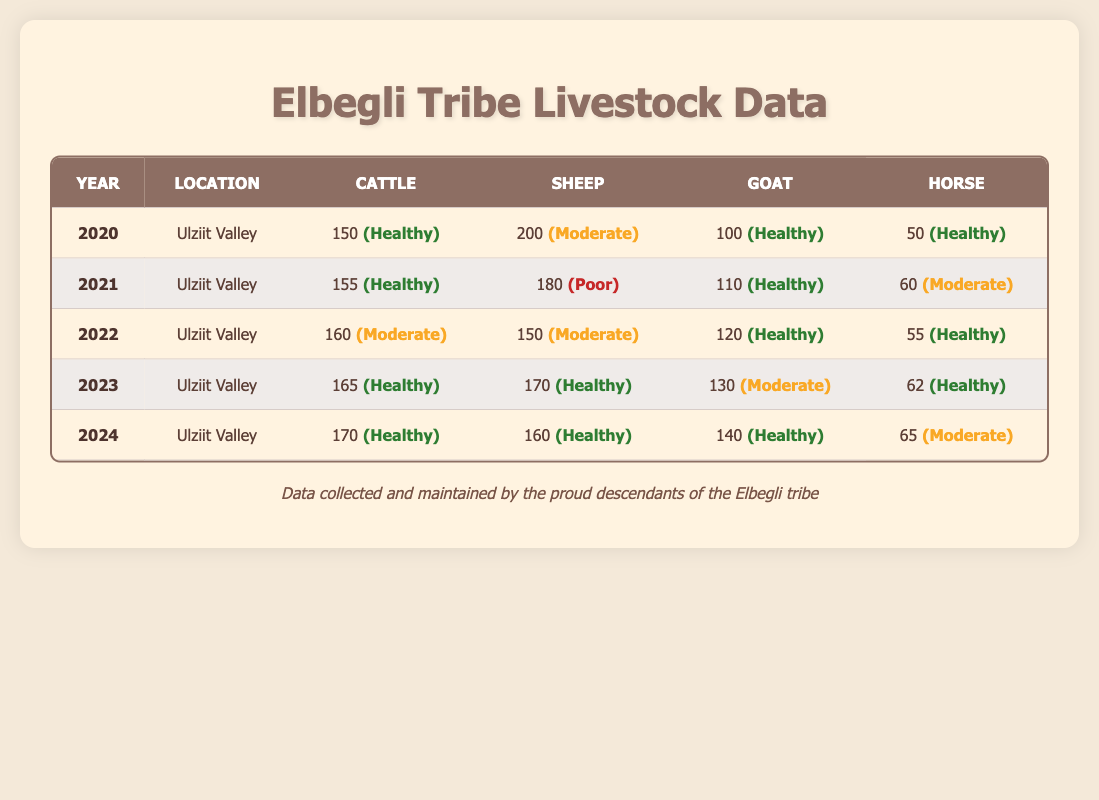What was the cattle count in 2022? The data for the year 2022 shows a cattle count of 160 in the Ulziit Valley.
Answer: 160 In which year did sheep health status drop to "Poor"? According to the table, the health status of sheep dropped to "Poor" in 2021.
Answer: 2021 What is the total number of horses counted from 2020 to 2024? The total horse counts for each year are 50 (2020) + 60 (2021) + 55 (2022) + 62 (2023) + 65 (2024) = 292.
Answer: 292 Which year had the highest number of sheep? The year 2020 had the highest sheep count of 200 in the data provided.
Answer: 2020 Is the health status of goats in 2024 healthy? Yes, the health status of goats in 2024 is indicated as "Healthy" in the table.
Answer: Yes What is the average cattle count from 2020 to 2024? The cattle counts are 150, 155, 160, 165, and 170. The average is calculated as (150 + 155 + 160 + 165 + 170) / 5 = 160.
Answer: 160 Which year's livestock data shows sheep health as "Moderate"? The years 2020 and 2022 both show sheep health as "Moderate" according to the table.
Answer: 2020 and 2022 What is the difference in goat count between 2020 and 2023? The goat count in 2020 is 100, and in 2023 it is 130. The difference is 130 - 100 = 30.
Answer: 30 In how many years did cattle health status remain "Healthy"? Cattle health was "Healthy" in 2020, 2021, 2023, and 2024, making it 4 years in total.
Answer: 4 What was the overall trend for sheep health from 2020 to 2024? Analyzing the table, sheep health statuses were "Moderate", "Poor", "Moderate", "Healthy", and "Healthy", showing an overall improvement trend from 2020 to 2024.
Answer: Improvement 